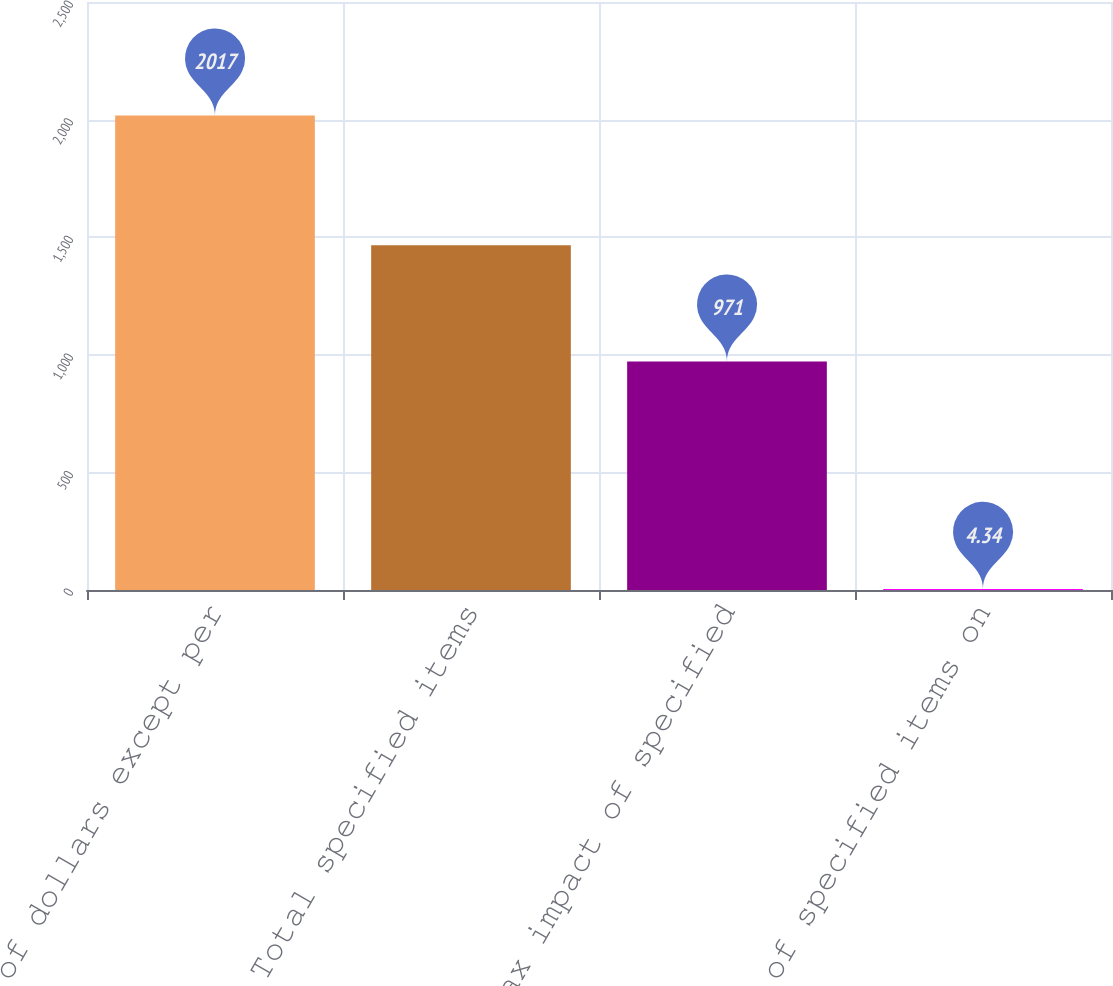<chart> <loc_0><loc_0><loc_500><loc_500><bar_chart><fcel>Millions of dollars except per<fcel>Total specified items<fcel>After-tax impact of specified<fcel>Impact of specified items on<nl><fcel>2017<fcel>1466<fcel>971<fcel>4.34<nl></chart> 